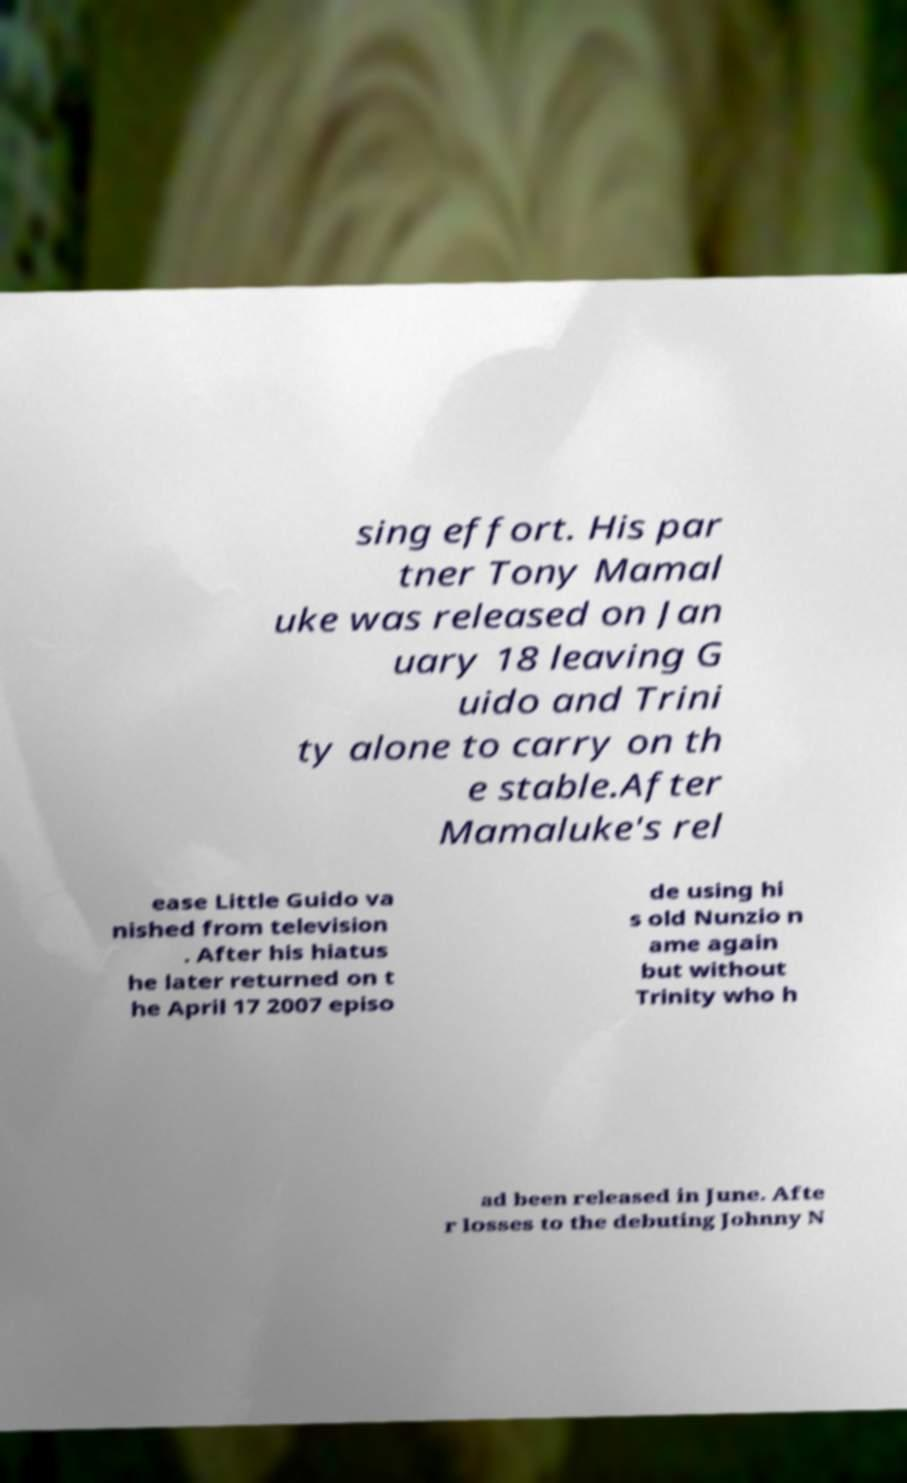I need the written content from this picture converted into text. Can you do that? sing effort. His par tner Tony Mamal uke was released on Jan uary 18 leaving G uido and Trini ty alone to carry on th e stable.After Mamaluke's rel ease Little Guido va nished from television . After his hiatus he later returned on t he April 17 2007 episo de using hi s old Nunzio n ame again but without Trinity who h ad been released in June. Afte r losses to the debuting Johnny N 